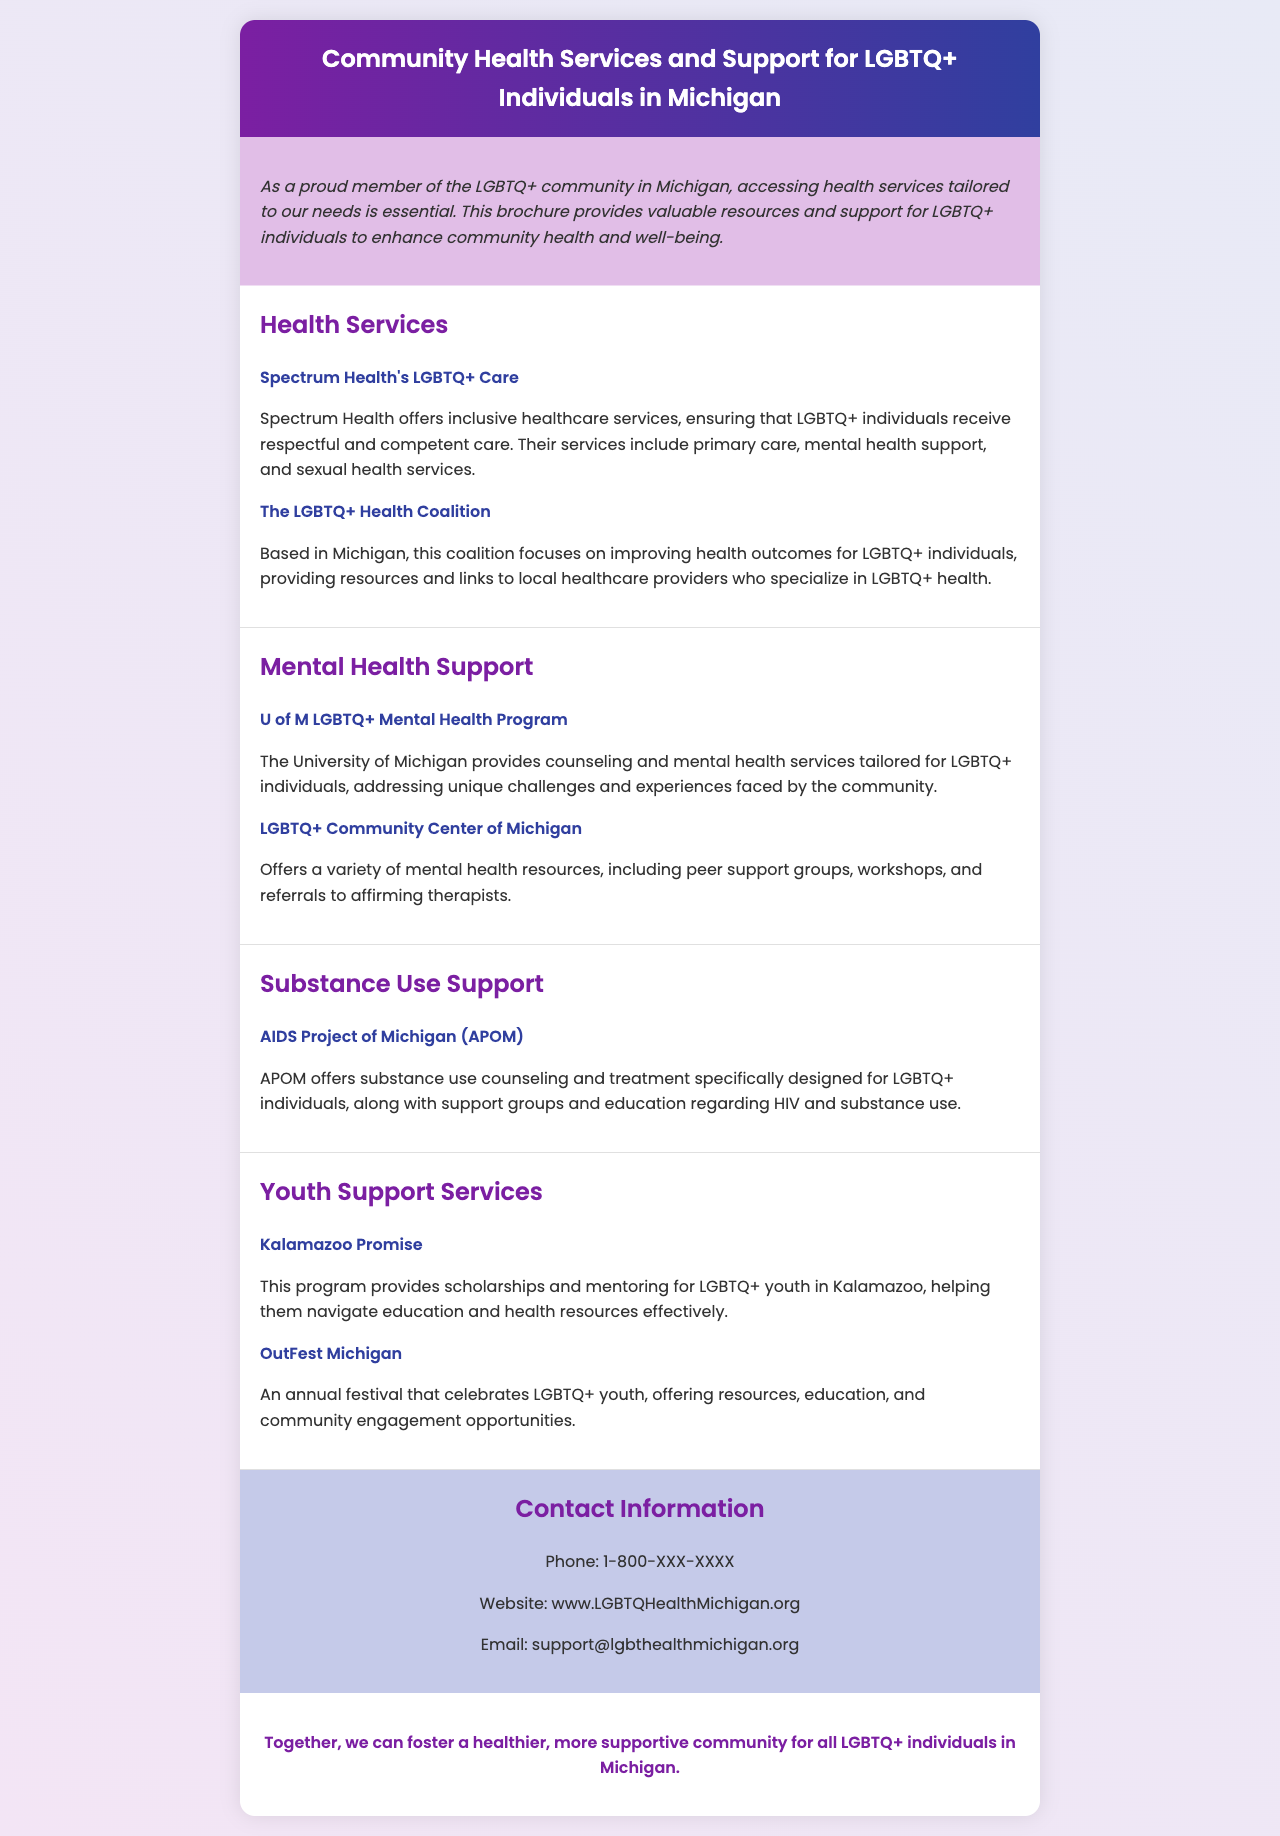What is the title of the brochure? The title of the brochure is found in the header section.
Answer: Community Health Services and Support for LGBTQ+ Individuals in Michigan What healthcare services does Spectrum Health provide? The documentation specifies the services offered by Spectrum Health.
Answer: Primary care, mental health support, and sexual health services Which program provides scholarships for LGBTQ+ youth in Kalamazoo? The question asks for a specific program mentioned in the youth support section of the document.
Answer: Kalamazoo Promise What organization focuses on improving health outcomes for LGBTQ+ individuals in Michigan? This is a specific name of an organization highlighted under health services.
Answer: The LGBTQ+ Health Coalition What type of support does AIDS Project of Michigan offer? The answer requires identifying the support services from the relevant section.
Answer: Substance use counseling and treatment How can one contact the health services? This is asking for contact information specified in the brochure.
Answer: Phone: 1-800-XXX-XXXX What is the main purpose of the introduction section? The question inquires about the overall intent stated in the introduction.
Answer: Enhancing community health and well-being What annual event celebrates LGBTQ+ youth according to the document? This question seeks specific event information regarding LGBTQ+ youth engagement.
Answer: OutFest Michigan 